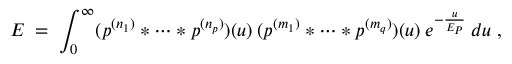Convert formula to latex. <formula><loc_0><loc_0><loc_500><loc_500>E \, = \, \int _ { 0 } ^ { \infty } ( p ^ { ( n _ { 1 } ) } * \cdots * p ^ { ( n _ { p } ) } ) ( u ) \, ( p ^ { ( m _ { 1 } ) } * \cdots * p ^ { ( m _ { q } ) } ) ( u ) \, e ^ { - \frac { u } { E _ { P } } } \, d u \, ,</formula> 